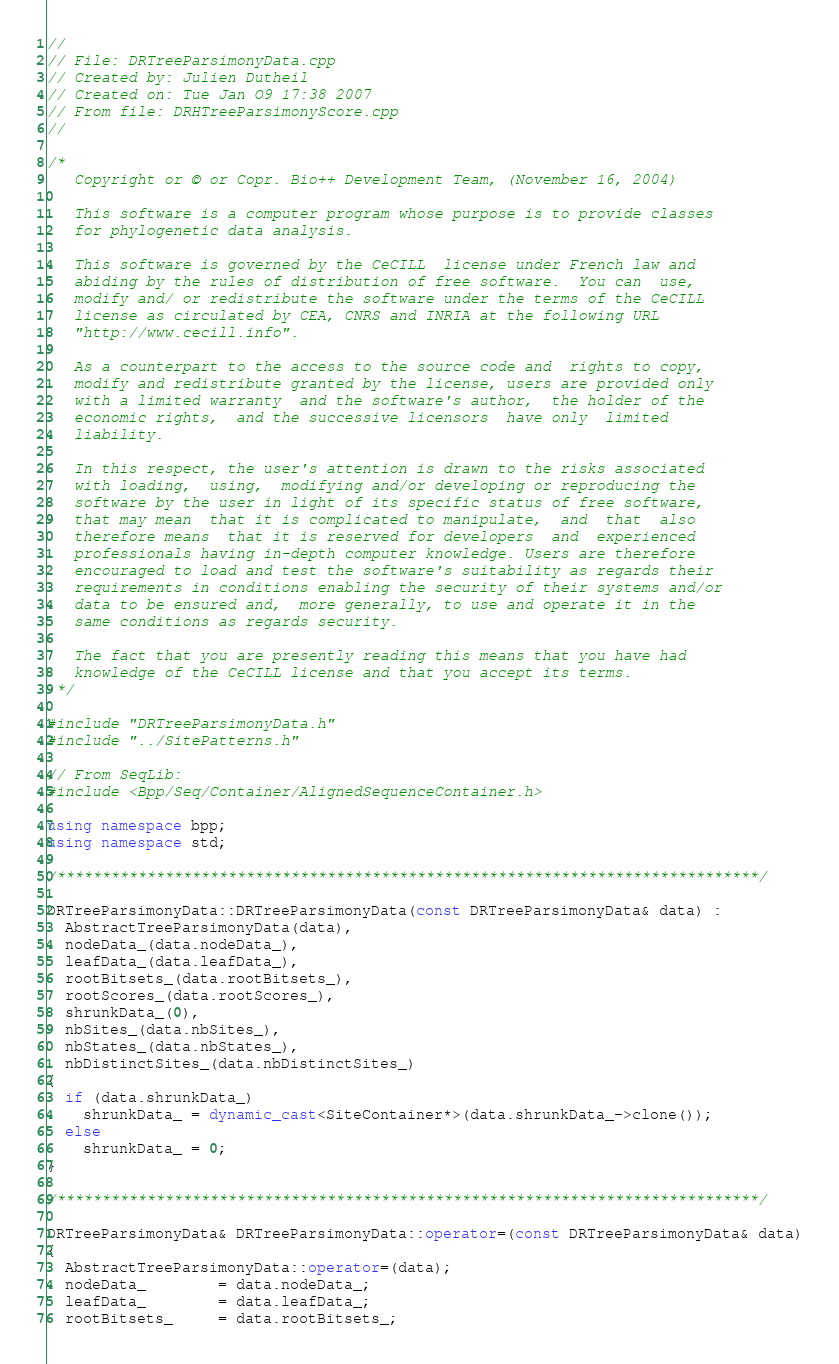<code> <loc_0><loc_0><loc_500><loc_500><_C++_>//
// File: DRTreeParsimonyData.cpp
// Created by: Julien Dutheil
// Created on: Tue Jan O9 17:38 2007
// From file: DRHTreeParsimonyScore.cpp
//

/*
   Copyright or © or Copr. Bio++ Development Team, (November 16, 2004)

   This software is a computer program whose purpose is to provide classes
   for phylogenetic data analysis.

   This software is governed by the CeCILL  license under French law and
   abiding by the rules of distribution of free software.  You can  use,
   modify and/ or redistribute the software under the terms of the CeCILL
   license as circulated by CEA, CNRS and INRIA at the following URL
   "http://www.cecill.info".

   As a counterpart to the access to the source code and  rights to copy,
   modify and redistribute granted by the license, users are provided only
   with a limited warranty  and the software's author,  the holder of the
   economic rights,  and the successive licensors  have only  limited
   liability.

   In this respect, the user's attention is drawn to the risks associated
   with loading,  using,  modifying and/or developing or reproducing the
   software by the user in light of its specific status of free software,
   that may mean  that it is complicated to manipulate,  and  that  also
   therefore means  that it is reserved for developers  and  experienced
   professionals having in-depth computer knowledge. Users are therefore
   encouraged to load and test the software's suitability as regards their
   requirements in conditions enabling the security of their systems and/or
   data to be ensured and,  more generally, to use and operate it in the
   same conditions as regards security.

   The fact that you are presently reading this means that you have had
   knowledge of the CeCILL license and that you accept its terms.
 */

#include "DRTreeParsimonyData.h"
#include "../SitePatterns.h"

// From SeqLib:
#include <Bpp/Seq/Container/AlignedSequenceContainer.h>

using namespace bpp;
using namespace std;

/******************************************************************************/

DRTreeParsimonyData::DRTreeParsimonyData(const DRTreeParsimonyData& data) :
  AbstractTreeParsimonyData(data),
  nodeData_(data.nodeData_),
  leafData_(data.leafData_),
  rootBitsets_(data.rootBitsets_),
  rootScores_(data.rootScores_),
  shrunkData_(0),
  nbSites_(data.nbSites_),
  nbStates_(data.nbStates_),
  nbDistinctSites_(data.nbDistinctSites_)
{
  if (data.shrunkData_)
    shrunkData_ = dynamic_cast<SiteContainer*>(data.shrunkData_->clone());
  else
    shrunkData_ = 0;
}

/******************************************************************************/

DRTreeParsimonyData& DRTreeParsimonyData::operator=(const DRTreeParsimonyData& data)
{
  AbstractTreeParsimonyData::operator=(data);
  nodeData_        = data.nodeData_;
  leafData_        = data.leafData_;
  rootBitsets_     = data.rootBitsets_;</code> 